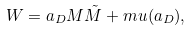<formula> <loc_0><loc_0><loc_500><loc_500>W = a _ { D } M \tilde { M } + m u ( a _ { D } ) ,</formula> 